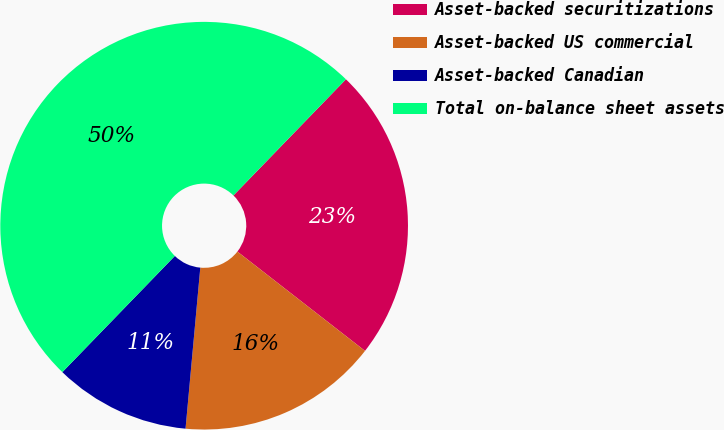Convert chart. <chart><loc_0><loc_0><loc_500><loc_500><pie_chart><fcel>Asset-backed securitizations<fcel>Asset-backed US commercial<fcel>Asset-backed Canadian<fcel>Total on-balance sheet assets<nl><fcel>23.28%<fcel>15.93%<fcel>10.79%<fcel>50.0%<nl></chart> 